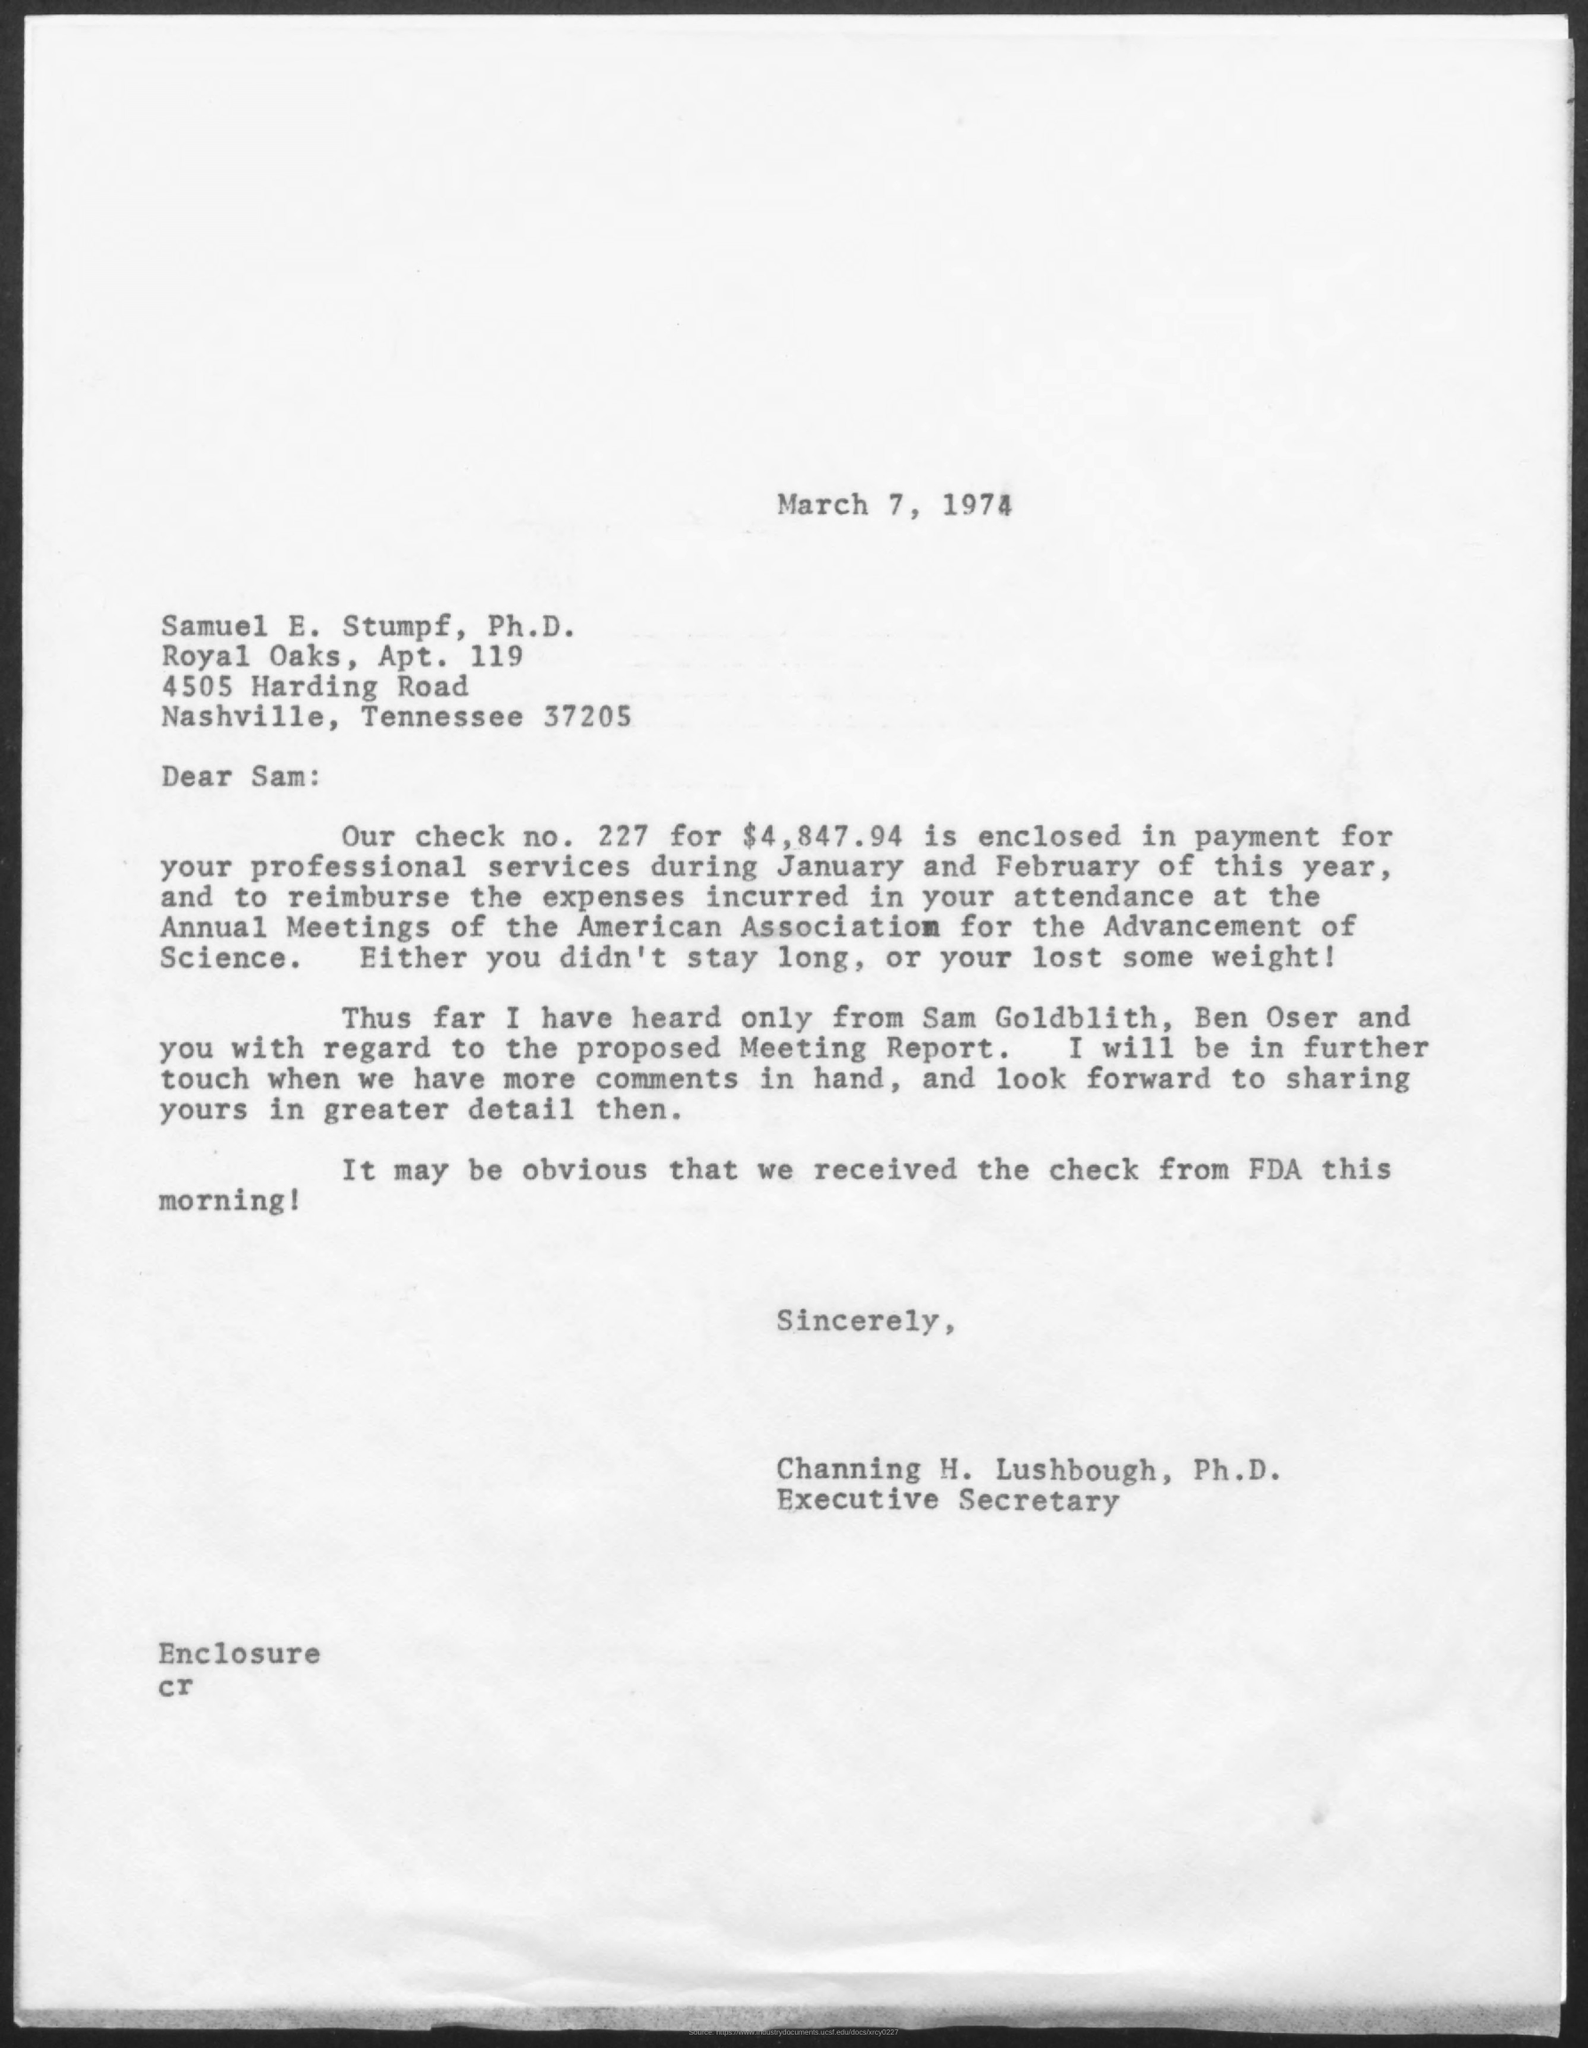Give some essential details in this illustration. The date mentioned in this letter is March 7, 1974. The letter's sender is Channing H. Lushbough. The check number mentioned in the letter is 227. The check amount mentioned in the letter is $4,847.94. 